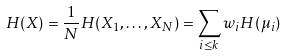<formula> <loc_0><loc_0><loc_500><loc_500>H ( X ) = \frac { 1 } { N } H ( X _ { 1 } , \dots , X _ { N } ) = \sum _ { i \leq k } w _ { i } H ( \mu _ { i } )</formula> 